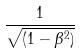<formula> <loc_0><loc_0><loc_500><loc_500>\frac { 1 } { \sqrt { ( 1 - \beta ^ { 2 } ) } }</formula> 